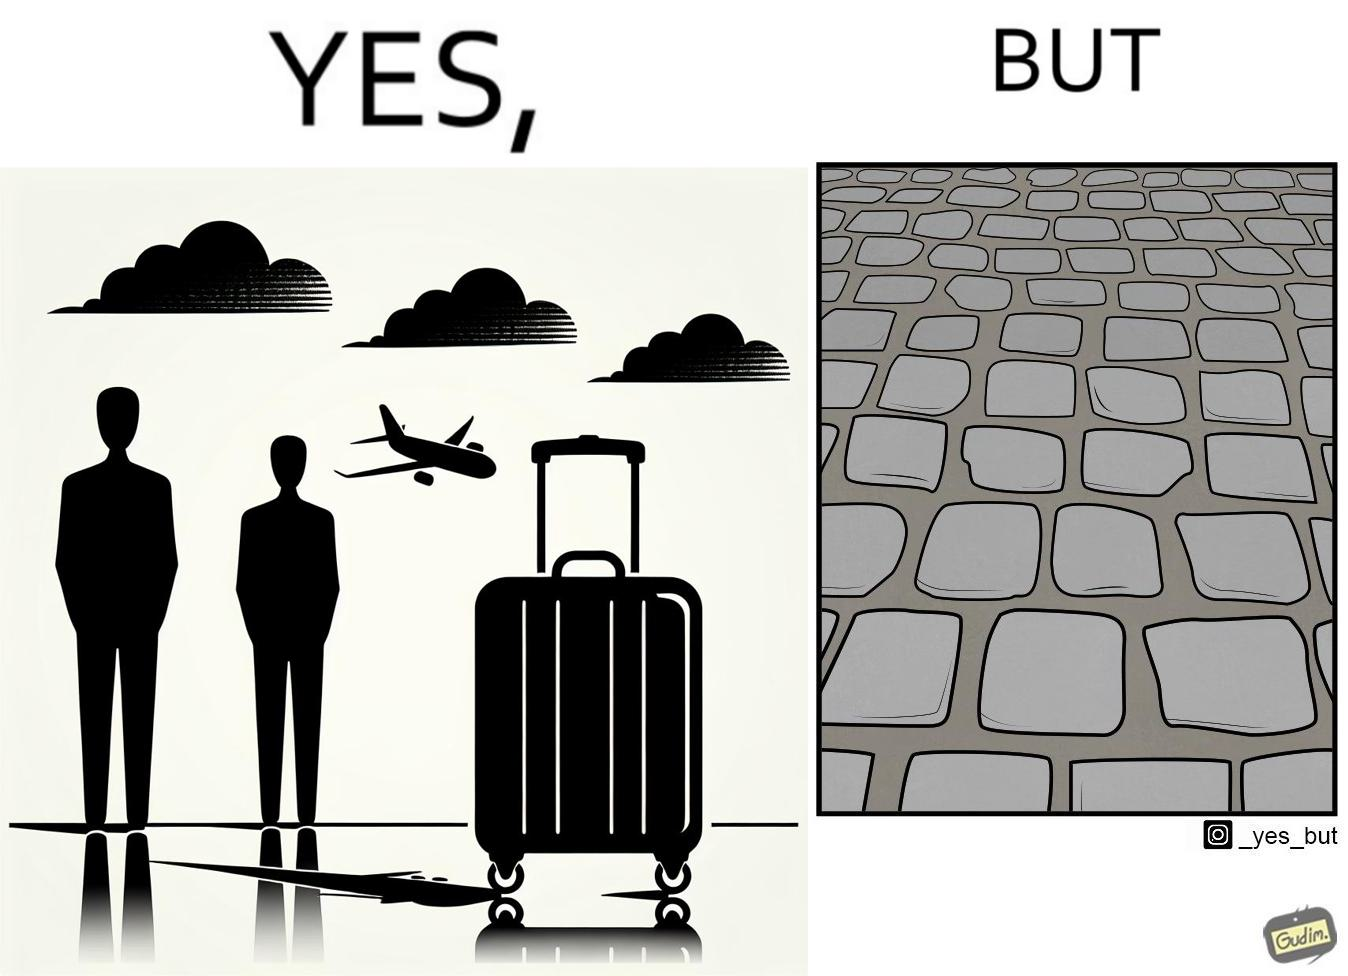Would you classify this image as satirical? Yes, this image is satirical. 